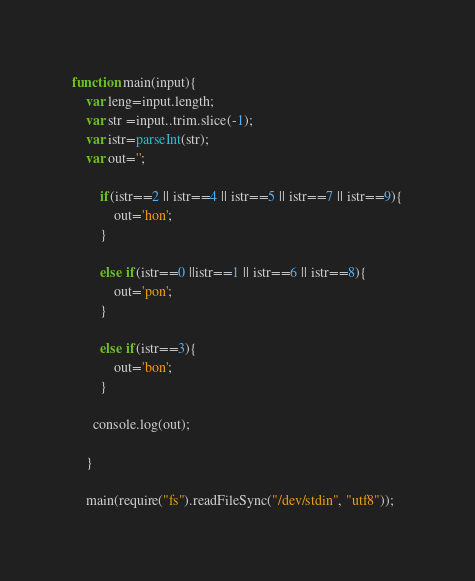Convert code to text. <code><loc_0><loc_0><loc_500><loc_500><_JavaScript_>function main(input){
    var leng=input.length;
    var str =input..trim.slice(-1);
    var istr=parseInt(str);
    var out='';
  
  	    if(istr==2 || istr==4 || istr==5 || istr==7 || istr==9){
            out='hon';
        }
    
        else if(istr==0 ||istr==1 || istr==6 || istr==8){
            out='pon';
        }
 
        else if(istr==3){
            out='bon';
        }
      
      console.log(out);
     
    }
     
    main(require("fs").readFileSync("/dev/stdin", "utf8"));</code> 